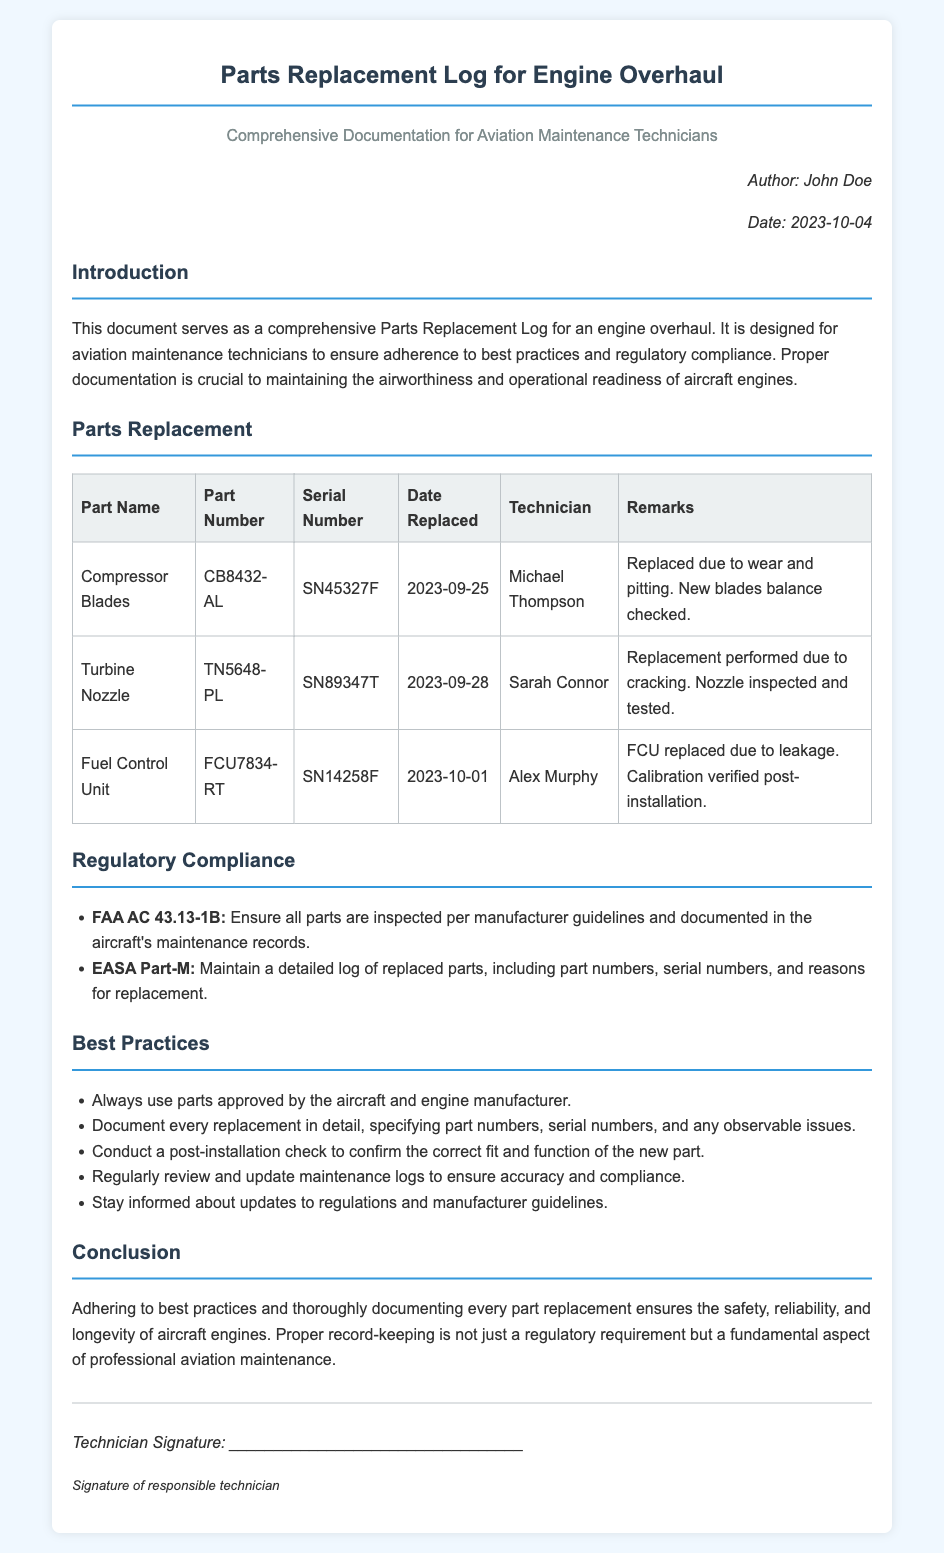what is the title of the document? The title is specified at the top of the document, which is "Parts Replacement Log for Engine Overhaul."
Answer: Parts Replacement Log for Engine Overhaul who authored the document? The author's name is mentioned in the meta section of the document as "John Doe."
Answer: John Doe what is the date of the document? The date is provided in the meta section, indicating when the document was created, which is "2023-10-04."
Answer: 2023-10-04 what part was replaced on 2023-09-25? This date is listed in the table under the "Date Replaced" column for the part "Compressor Blades."
Answer: Compressor Blades how many parts are listed in the Parts Replacement section? The document lists three items in the Parts Replacement table, which can be counted in the table section.
Answer: 3 what was the reason for replacing the Fuel Control Unit? The reason for replacement is mentioned in the remarks for the Fuel Control Unit. It states "leakage."
Answer: leakage which guidelines must be followed according to the regulatory compliance section? The document references two main compliance guidelines, which are found in the regulatory compliance section.
Answer: FAA AC 43.13-1B and EASA Part-M what should be documented after every replacement? A detail is mentioned in the best practices section, outlining what must be documented after replacement.
Answer: part numbers, serial numbers, and any observable issues what is the primary focus of the document? The introduction describes the main purpose of the document clearly, which is centered around maintenance practices.
Answer: comprehensive Parts Replacement Log 